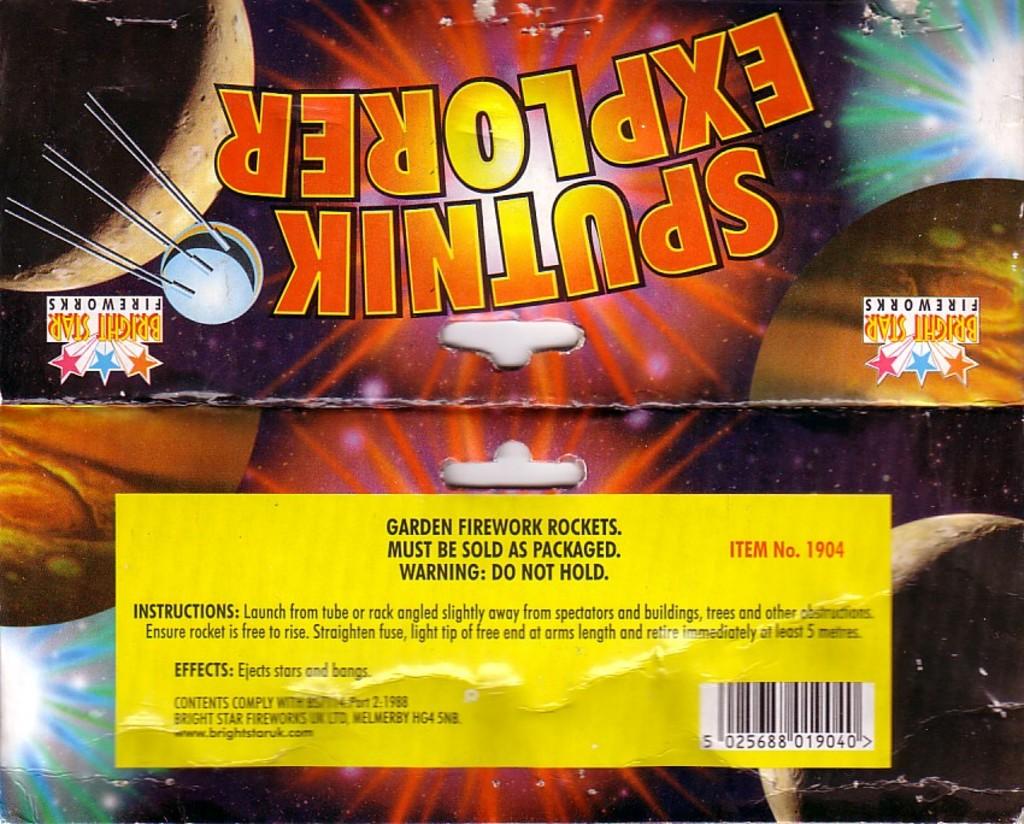Are these a type of firework?
Make the answer very short. Yes. What is the item number for these fireworks?
Make the answer very short. 1904. 